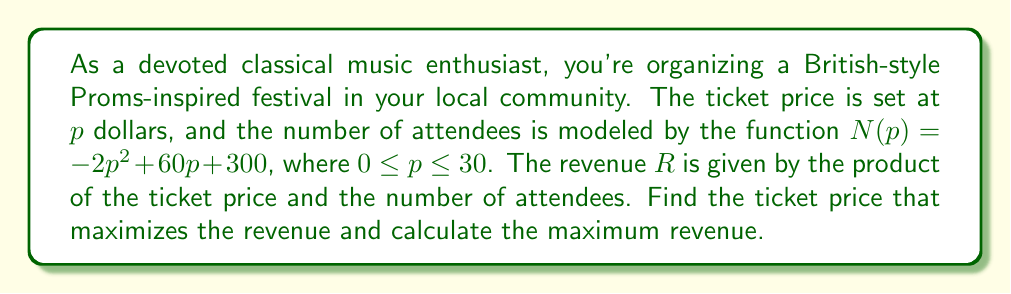Provide a solution to this math problem. Let's approach this step-by-step:

1) The revenue function $R(p)$ is the product of the ticket price $p$ and the number of attendees $N(p)$:

   $R(p) = p \cdot N(p) = p(-2p^2 + 60p + 300)$

2) Expanding this:

   $R(p) = -2p^3 + 60p^2 + 300p$

3) To find the maximum revenue, we need to find where the derivative of $R(p)$ equals zero:

   $R'(p) = -6p^2 + 120p + 300$

4) Set $R'(p) = 0$:

   $-6p^2 + 120p + 300 = 0$

5) This is a quadratic equation. We can solve it using the quadratic formula:

   $p = \frac{-b \pm \sqrt{b^2 - 4ac}}{2a}$

   Where $a = -6$, $b = 120$, and $c = 300$

6) Substituting these values:

   $p = \frac{-120 \pm \sqrt{120^2 - 4(-6)(300)}}{2(-6)}$

7) Simplifying:

   $p = \frac{-120 \pm \sqrt{14400 + 7200}}{-12} = \frac{-120 \pm \sqrt{21600}}{-12} = \frac{-120 \pm 146.97}{-12}$

8) This gives us two solutions:

   $p_1 = \frac{-120 + 146.97}{-12} \approx 22.25$
   $p_2 = \frac{-120 - 146.97}{-12} \approx -2.25$

9) Since price can't be negative, we discard $p_2$. Therefore, the revenue-maximizing price is approximately $22.25$.

10) To find the maximum revenue, we substitute this price back into our original revenue function:

    $R(22.25) = -2(22.25)^3 + 60(22.25)^2 + 300(22.25)$

11) Calculating this gives us the maximum revenue.
Answer: The ticket price that maximizes revenue is approximately $22.25. The maximum revenue is approximately $5,578.52. 